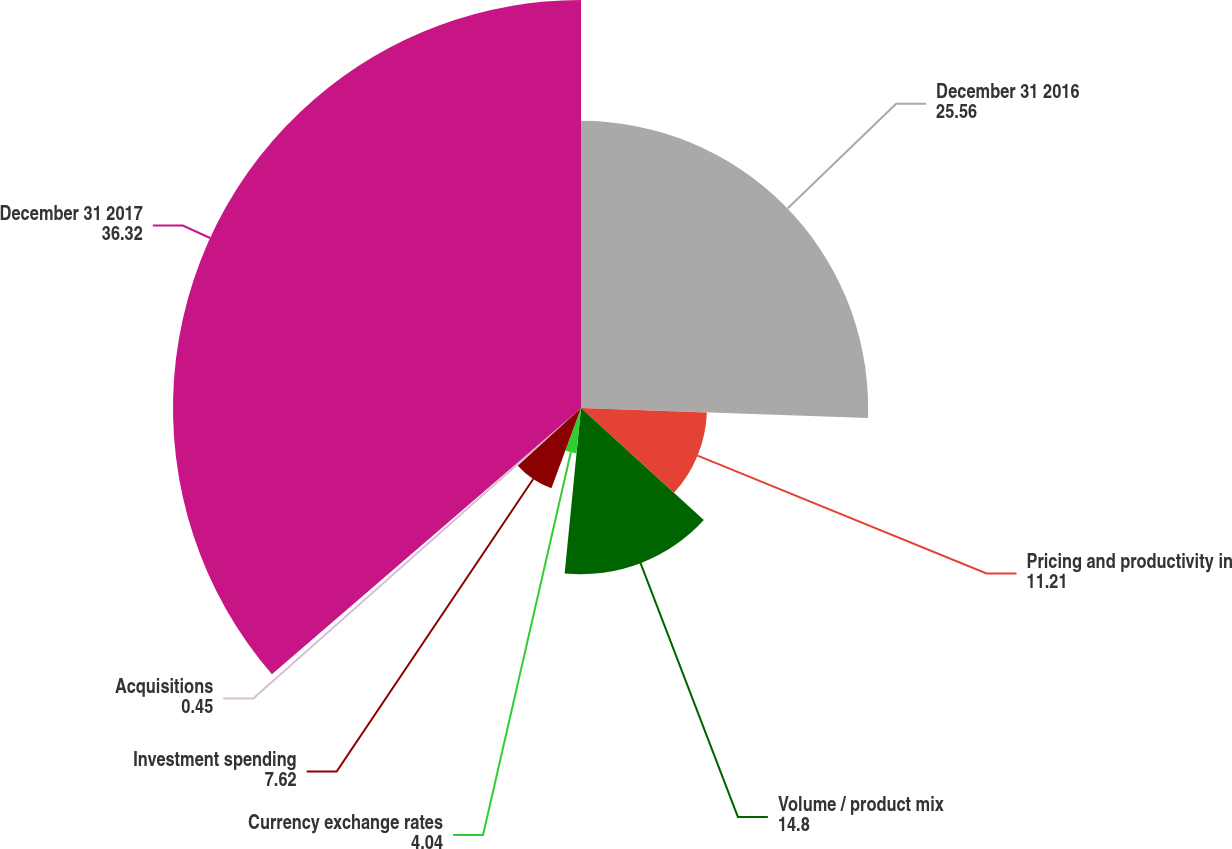Convert chart. <chart><loc_0><loc_0><loc_500><loc_500><pie_chart><fcel>December 31 2016<fcel>Pricing and productivity in<fcel>Volume / product mix<fcel>Currency exchange rates<fcel>Investment spending<fcel>Acquisitions<fcel>December 31 2017<nl><fcel>25.56%<fcel>11.21%<fcel>14.8%<fcel>4.04%<fcel>7.62%<fcel>0.45%<fcel>36.32%<nl></chart> 